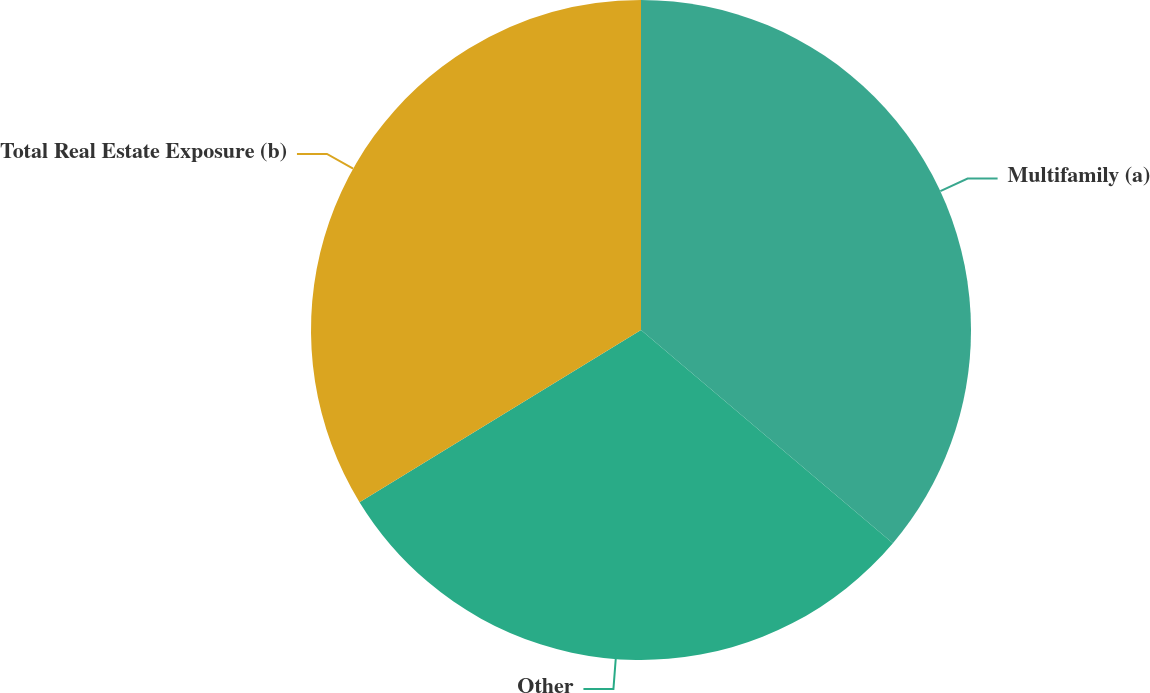Convert chart. <chart><loc_0><loc_0><loc_500><loc_500><pie_chart><fcel>Multifamily (a)<fcel>Other<fcel>Total Real Estate Exposure (b)<nl><fcel>36.18%<fcel>30.08%<fcel>33.74%<nl></chart> 